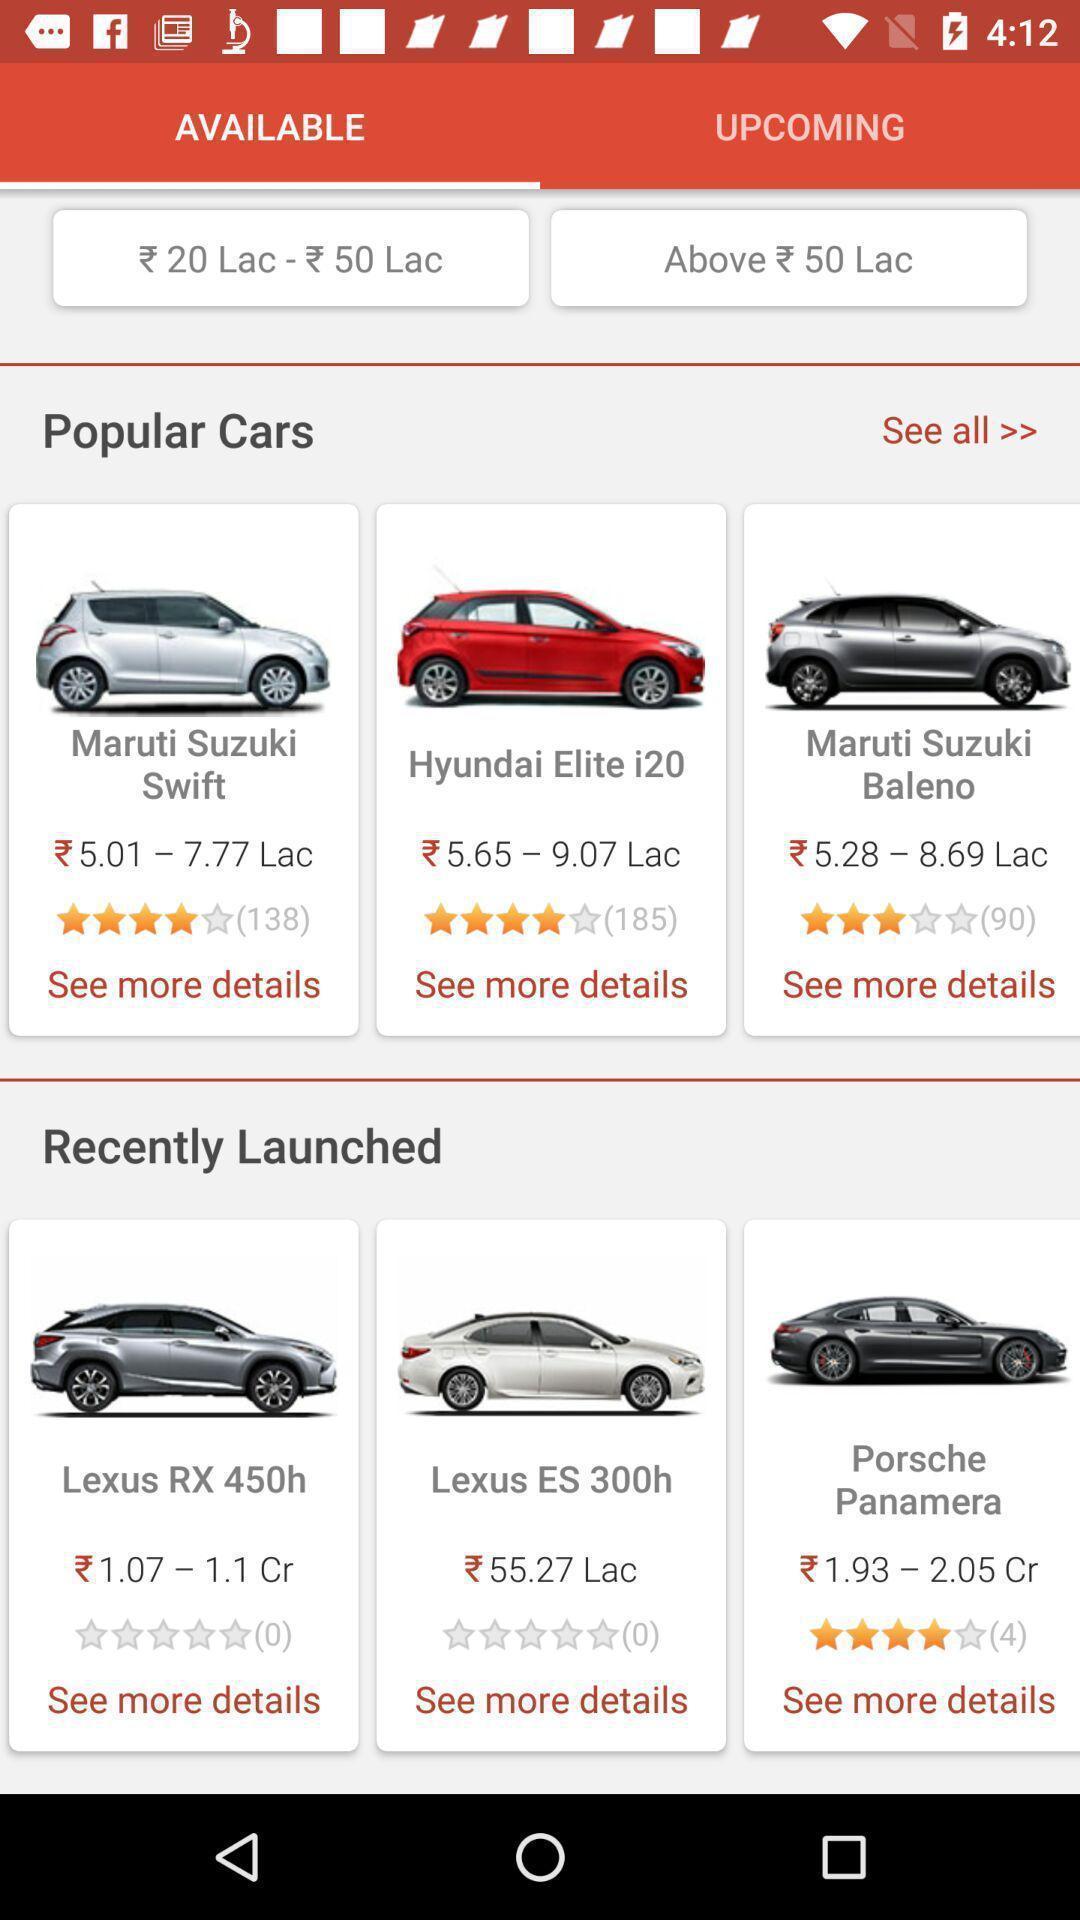What can you discern from this picture? Screen shows available popular cars. 